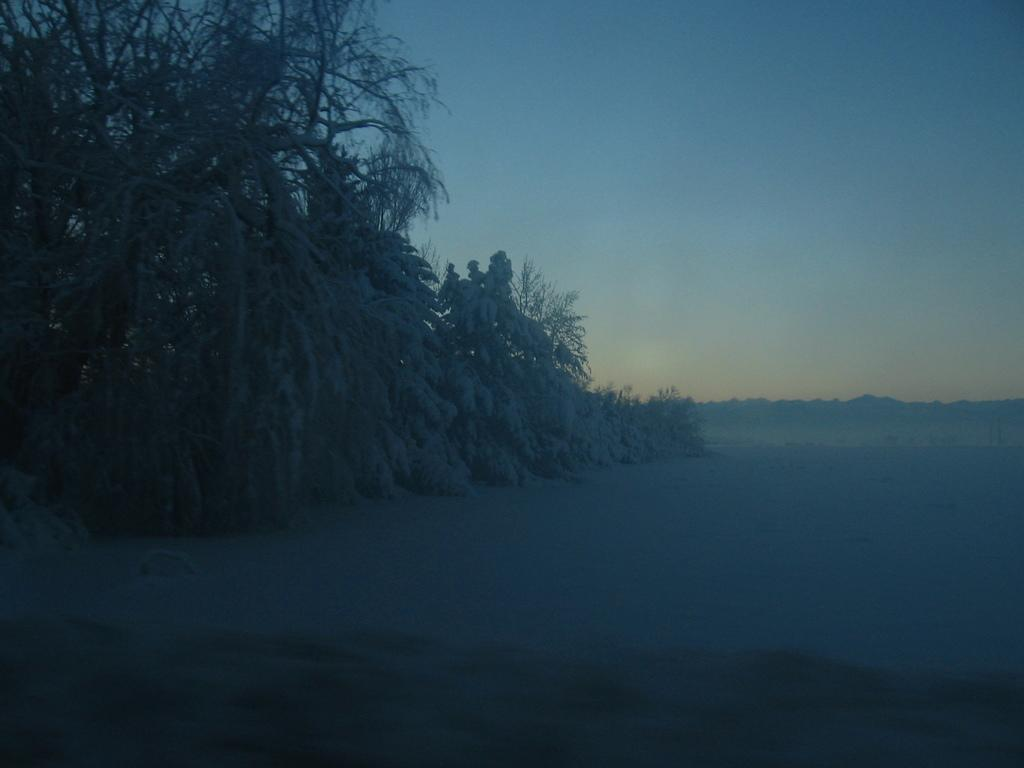What is the condition of the land in the image? The land in the image is covered with snow. What type of vegetation can be seen in the image? There are trees in the image. What color is the sky in the image? The sky is blue in color. What type of calendar is hanging on the tree in the image? There is no calendar present in the image; it only features snow-covered land, trees, and a blue sky. How many eggs can be seen in the image? There are no eggs visible in the image. 